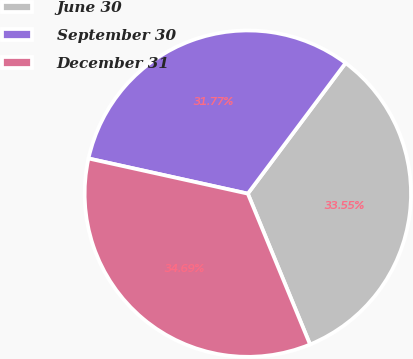<chart> <loc_0><loc_0><loc_500><loc_500><pie_chart><fcel>June 30<fcel>September 30<fcel>December 31<nl><fcel>33.55%<fcel>31.77%<fcel>34.69%<nl></chart> 